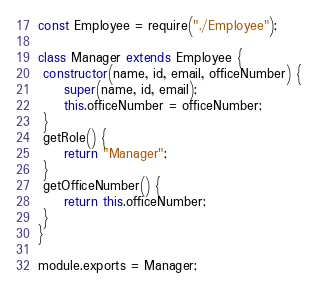Convert code to text. <code><loc_0><loc_0><loc_500><loc_500><_JavaScript_>const Employee = require("./Employee");

class Manager extends Employee { 
 constructor(name, id, email, officeNumber) {
     super(name, id, email);
     this.officeNumber = officeNumber;
 }
 getRole() {
     return "Manager";
 }
 getOfficeNumber() {
     return this.officeNumber;
 }
}

module.exports = Manager;</code> 